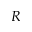Convert formula to latex. <formula><loc_0><loc_0><loc_500><loc_500>R</formula> 